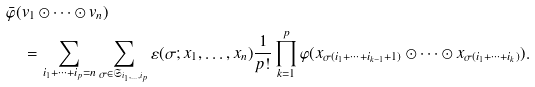<formula> <loc_0><loc_0><loc_500><loc_500>& \bar { \varphi } ( v _ { 1 } \odot \dots \odot v _ { n } ) \\ & \quad = \sum _ { i _ { 1 } + \cdots + i _ { p } = n } \sum _ { \sigma \in \mathfrak { S } _ { i _ { 1 } , \dots , i _ { p } } } \varepsilon ( \sigma ; x _ { 1 } , \dots , x _ { n } ) \frac { 1 } { p ! } \prod _ { k = 1 } ^ { p } \varphi ( x _ { \sigma ( i _ { 1 } + \cdots + i _ { k - 1 } + 1 ) } \odot \cdots \odot x _ { \sigma ( i _ { 1 } + \cdots + i _ { k } ) } ) .</formula> 